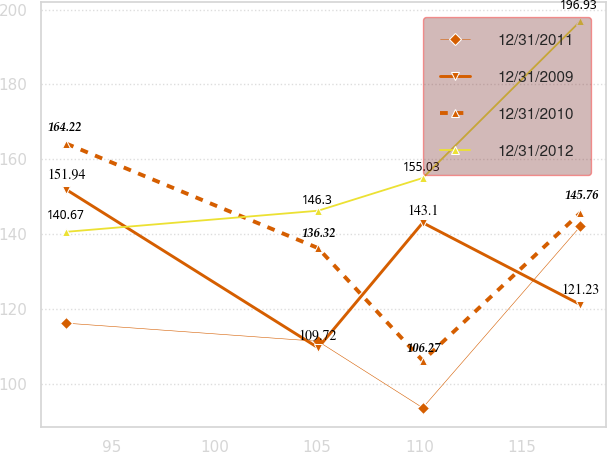Convert chart. <chart><loc_0><loc_0><loc_500><loc_500><line_chart><ecel><fcel>12/31/2011<fcel>12/31/2009<fcel>12/31/2010<fcel>12/31/2012<nl><fcel>92.78<fcel>116.29<fcel>151.94<fcel>164.22<fcel>140.67<nl><fcel>105.06<fcel>111.44<fcel>109.72<fcel>136.32<fcel>146.3<nl><fcel>110.16<fcel>93.7<fcel>143.1<fcel>106.27<fcel>155.03<nl><fcel>117.85<fcel>142.16<fcel>121.23<fcel>145.76<fcel>196.93<nl></chart> 